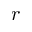<formula> <loc_0><loc_0><loc_500><loc_500>r</formula> 